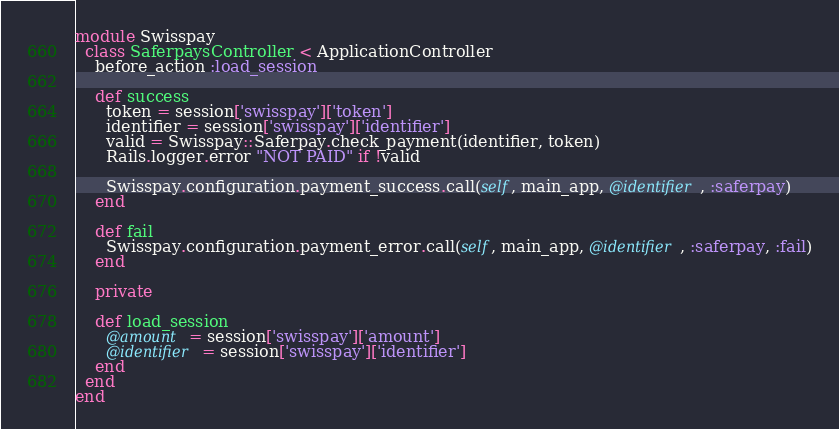Convert code to text. <code><loc_0><loc_0><loc_500><loc_500><_Ruby_>module Swisspay
  class SaferpaysController < ApplicationController
    before_action :load_session
    
    def success
      token = session['swisspay']['token']
      identifier = session['swisspay']['identifier']
      valid = Swisspay::Saferpay.check_payment(identifier, token)
      Rails.logger.error "NOT PAID" if !valid

      Swisspay.configuration.payment_success.call(self, main_app, @identifier, :saferpay)
    end

    def fail
      Swisspay.configuration.payment_error.call(self, main_app, @identifier, :saferpay, :fail)
    end

    private

    def load_session
      @amount = session['swisspay']['amount']
      @identifier = session['swisspay']['identifier']
    end
  end
end
</code> 